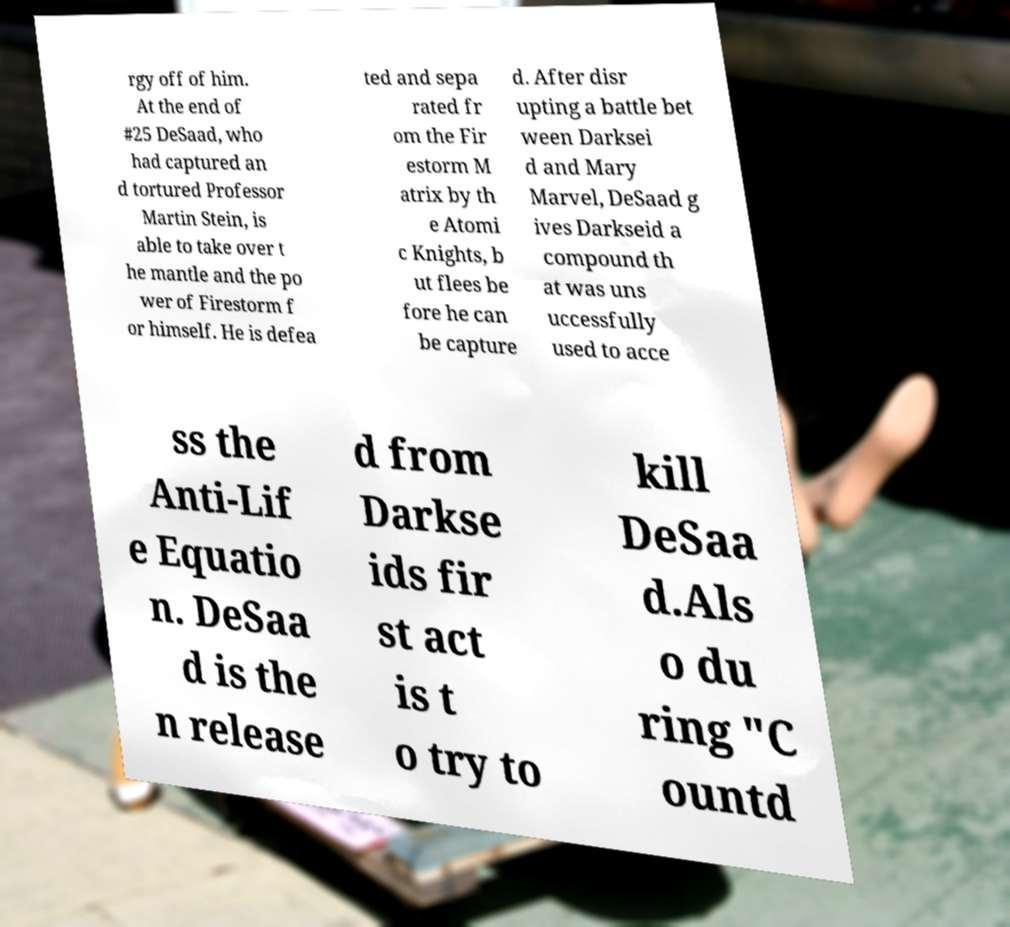I need the written content from this picture converted into text. Can you do that? rgy off of him. At the end of #25 DeSaad, who had captured an d tortured Professor Martin Stein, is able to take over t he mantle and the po wer of Firestorm f or himself. He is defea ted and sepa rated fr om the Fir estorm M atrix by th e Atomi c Knights, b ut flees be fore he can be capture d. After disr upting a battle bet ween Darksei d and Mary Marvel, DeSaad g ives Darkseid a compound th at was uns uccessfully used to acce ss the Anti-Lif e Equatio n. DeSaa d is the n release d from Darkse ids fir st act is t o try to kill DeSaa d.Als o du ring "C ountd 